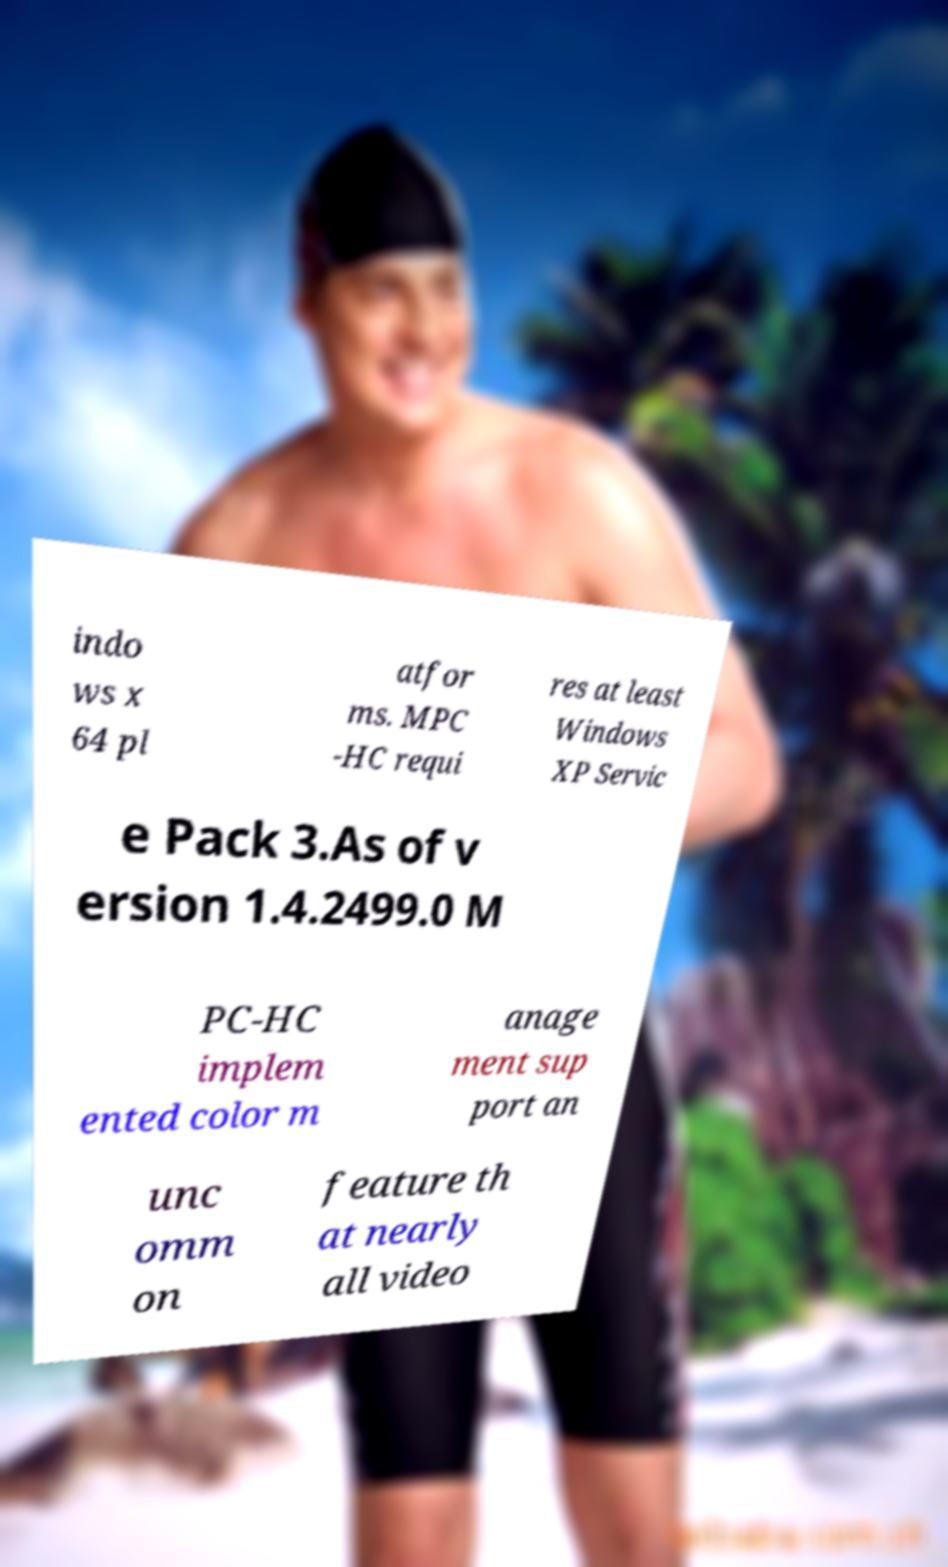For documentation purposes, I need the text within this image transcribed. Could you provide that? indo ws x 64 pl atfor ms. MPC -HC requi res at least Windows XP Servic e Pack 3.As of v ersion 1.4.2499.0 M PC-HC implem ented color m anage ment sup port an unc omm on feature th at nearly all video 